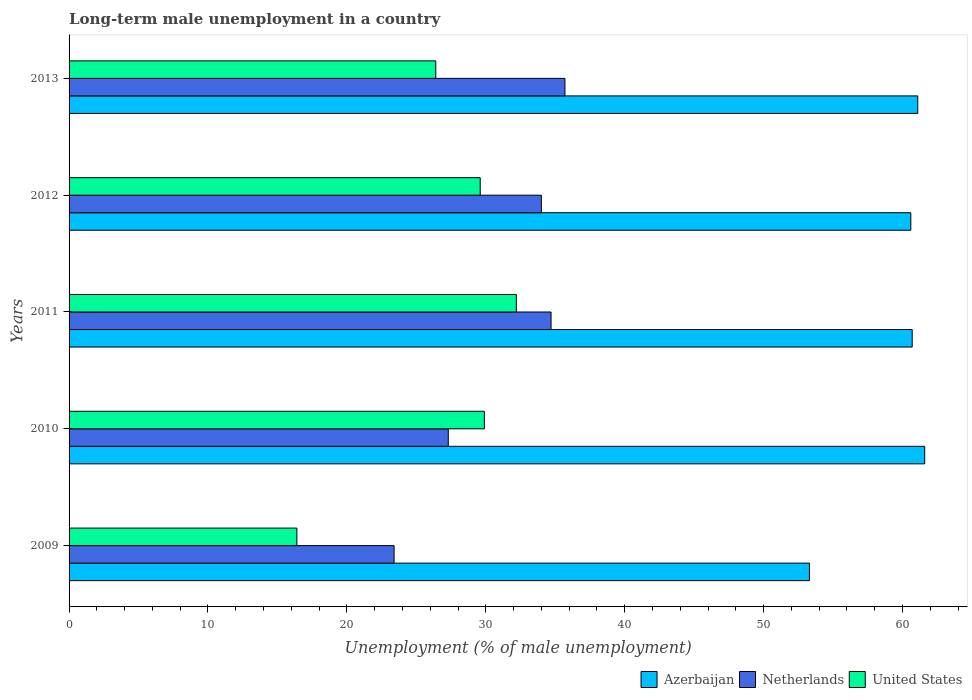Are the number of bars per tick equal to the number of legend labels?
Your answer should be very brief. Yes. How many bars are there on the 2nd tick from the top?
Offer a very short reply. 3. In how many cases, is the number of bars for a given year not equal to the number of legend labels?
Offer a very short reply. 0. What is the percentage of long-term unemployed male population in United States in 2013?
Offer a very short reply. 26.4. Across all years, what is the maximum percentage of long-term unemployed male population in United States?
Your answer should be compact. 32.2. Across all years, what is the minimum percentage of long-term unemployed male population in Netherlands?
Keep it short and to the point. 23.4. What is the total percentage of long-term unemployed male population in Netherlands in the graph?
Your response must be concise. 155.1. What is the difference between the percentage of long-term unemployed male population in United States in 2009 and that in 2012?
Your response must be concise. -13.2. What is the difference between the percentage of long-term unemployed male population in Netherlands in 2009 and the percentage of long-term unemployed male population in United States in 2013?
Your answer should be compact. -3. What is the average percentage of long-term unemployed male population in United States per year?
Your answer should be very brief. 26.9. In the year 2010, what is the difference between the percentage of long-term unemployed male population in United States and percentage of long-term unemployed male population in Netherlands?
Give a very brief answer. 2.6. In how many years, is the percentage of long-term unemployed male population in Netherlands greater than 56 %?
Your answer should be compact. 0. What is the ratio of the percentage of long-term unemployed male population in Azerbaijan in 2009 to that in 2011?
Provide a short and direct response. 0.88. Is the difference between the percentage of long-term unemployed male population in United States in 2009 and 2010 greater than the difference between the percentage of long-term unemployed male population in Netherlands in 2009 and 2010?
Your answer should be compact. No. What is the difference between the highest and the second highest percentage of long-term unemployed male population in United States?
Provide a succinct answer. 2.3. What is the difference between the highest and the lowest percentage of long-term unemployed male population in United States?
Provide a short and direct response. 15.8. Is the sum of the percentage of long-term unemployed male population in United States in 2012 and 2013 greater than the maximum percentage of long-term unemployed male population in Netherlands across all years?
Your response must be concise. Yes. How many bars are there?
Keep it short and to the point. 15. Does the graph contain grids?
Your answer should be very brief. No. Where does the legend appear in the graph?
Provide a succinct answer. Bottom right. How many legend labels are there?
Make the answer very short. 3. How are the legend labels stacked?
Give a very brief answer. Horizontal. What is the title of the graph?
Keep it short and to the point. Long-term male unemployment in a country. What is the label or title of the X-axis?
Your answer should be very brief. Unemployment (% of male unemployment). What is the Unemployment (% of male unemployment) in Azerbaijan in 2009?
Give a very brief answer. 53.3. What is the Unemployment (% of male unemployment) of Netherlands in 2009?
Your response must be concise. 23.4. What is the Unemployment (% of male unemployment) of United States in 2009?
Your response must be concise. 16.4. What is the Unemployment (% of male unemployment) in Azerbaijan in 2010?
Ensure brevity in your answer.  61.6. What is the Unemployment (% of male unemployment) in Netherlands in 2010?
Make the answer very short. 27.3. What is the Unemployment (% of male unemployment) of United States in 2010?
Make the answer very short. 29.9. What is the Unemployment (% of male unemployment) in Azerbaijan in 2011?
Your answer should be very brief. 60.7. What is the Unemployment (% of male unemployment) of Netherlands in 2011?
Provide a short and direct response. 34.7. What is the Unemployment (% of male unemployment) of United States in 2011?
Ensure brevity in your answer.  32.2. What is the Unemployment (% of male unemployment) of Azerbaijan in 2012?
Offer a terse response. 60.6. What is the Unemployment (% of male unemployment) of Netherlands in 2012?
Give a very brief answer. 34. What is the Unemployment (% of male unemployment) of United States in 2012?
Ensure brevity in your answer.  29.6. What is the Unemployment (% of male unemployment) in Azerbaijan in 2013?
Give a very brief answer. 61.1. What is the Unemployment (% of male unemployment) in Netherlands in 2013?
Your answer should be very brief. 35.7. What is the Unemployment (% of male unemployment) of United States in 2013?
Provide a short and direct response. 26.4. Across all years, what is the maximum Unemployment (% of male unemployment) of Azerbaijan?
Keep it short and to the point. 61.6. Across all years, what is the maximum Unemployment (% of male unemployment) of Netherlands?
Your response must be concise. 35.7. Across all years, what is the maximum Unemployment (% of male unemployment) in United States?
Provide a short and direct response. 32.2. Across all years, what is the minimum Unemployment (% of male unemployment) of Azerbaijan?
Your answer should be very brief. 53.3. Across all years, what is the minimum Unemployment (% of male unemployment) of Netherlands?
Your response must be concise. 23.4. Across all years, what is the minimum Unemployment (% of male unemployment) in United States?
Your answer should be very brief. 16.4. What is the total Unemployment (% of male unemployment) of Azerbaijan in the graph?
Provide a short and direct response. 297.3. What is the total Unemployment (% of male unemployment) in Netherlands in the graph?
Provide a succinct answer. 155.1. What is the total Unemployment (% of male unemployment) in United States in the graph?
Your response must be concise. 134.5. What is the difference between the Unemployment (% of male unemployment) in Azerbaijan in 2009 and that in 2010?
Your response must be concise. -8.3. What is the difference between the Unemployment (% of male unemployment) of Netherlands in 2009 and that in 2010?
Keep it short and to the point. -3.9. What is the difference between the Unemployment (% of male unemployment) in United States in 2009 and that in 2010?
Make the answer very short. -13.5. What is the difference between the Unemployment (% of male unemployment) in United States in 2009 and that in 2011?
Give a very brief answer. -15.8. What is the difference between the Unemployment (% of male unemployment) of Azerbaijan in 2009 and that in 2012?
Provide a short and direct response. -7.3. What is the difference between the Unemployment (% of male unemployment) in Netherlands in 2009 and that in 2012?
Give a very brief answer. -10.6. What is the difference between the Unemployment (% of male unemployment) of Azerbaijan in 2009 and that in 2013?
Keep it short and to the point. -7.8. What is the difference between the Unemployment (% of male unemployment) in Netherlands in 2009 and that in 2013?
Your answer should be compact. -12.3. What is the difference between the Unemployment (% of male unemployment) of United States in 2009 and that in 2013?
Offer a terse response. -10. What is the difference between the Unemployment (% of male unemployment) of Netherlands in 2010 and that in 2011?
Make the answer very short. -7.4. What is the difference between the Unemployment (% of male unemployment) in Azerbaijan in 2010 and that in 2012?
Provide a short and direct response. 1. What is the difference between the Unemployment (% of male unemployment) in Netherlands in 2010 and that in 2012?
Your response must be concise. -6.7. What is the difference between the Unemployment (% of male unemployment) in Azerbaijan in 2010 and that in 2013?
Your response must be concise. 0.5. What is the difference between the Unemployment (% of male unemployment) in Netherlands in 2010 and that in 2013?
Your answer should be compact. -8.4. What is the difference between the Unemployment (% of male unemployment) of Azerbaijan in 2011 and that in 2012?
Give a very brief answer. 0.1. What is the difference between the Unemployment (% of male unemployment) in Netherlands in 2011 and that in 2012?
Offer a terse response. 0.7. What is the difference between the Unemployment (% of male unemployment) of United States in 2011 and that in 2012?
Your response must be concise. 2.6. What is the difference between the Unemployment (% of male unemployment) of Azerbaijan in 2011 and that in 2013?
Make the answer very short. -0.4. What is the difference between the Unemployment (% of male unemployment) in Netherlands in 2011 and that in 2013?
Offer a terse response. -1. What is the difference between the Unemployment (% of male unemployment) of Azerbaijan in 2012 and that in 2013?
Provide a succinct answer. -0.5. What is the difference between the Unemployment (% of male unemployment) in United States in 2012 and that in 2013?
Provide a short and direct response. 3.2. What is the difference between the Unemployment (% of male unemployment) in Azerbaijan in 2009 and the Unemployment (% of male unemployment) in Netherlands in 2010?
Offer a very short reply. 26. What is the difference between the Unemployment (% of male unemployment) in Azerbaijan in 2009 and the Unemployment (% of male unemployment) in United States in 2010?
Your answer should be very brief. 23.4. What is the difference between the Unemployment (% of male unemployment) in Azerbaijan in 2009 and the Unemployment (% of male unemployment) in Netherlands in 2011?
Provide a succinct answer. 18.6. What is the difference between the Unemployment (% of male unemployment) in Azerbaijan in 2009 and the Unemployment (% of male unemployment) in United States in 2011?
Keep it short and to the point. 21.1. What is the difference between the Unemployment (% of male unemployment) in Netherlands in 2009 and the Unemployment (% of male unemployment) in United States in 2011?
Your response must be concise. -8.8. What is the difference between the Unemployment (% of male unemployment) of Azerbaijan in 2009 and the Unemployment (% of male unemployment) of Netherlands in 2012?
Provide a succinct answer. 19.3. What is the difference between the Unemployment (% of male unemployment) in Azerbaijan in 2009 and the Unemployment (% of male unemployment) in United States in 2012?
Make the answer very short. 23.7. What is the difference between the Unemployment (% of male unemployment) in Netherlands in 2009 and the Unemployment (% of male unemployment) in United States in 2012?
Provide a succinct answer. -6.2. What is the difference between the Unemployment (% of male unemployment) of Azerbaijan in 2009 and the Unemployment (% of male unemployment) of Netherlands in 2013?
Offer a very short reply. 17.6. What is the difference between the Unemployment (% of male unemployment) in Azerbaijan in 2009 and the Unemployment (% of male unemployment) in United States in 2013?
Make the answer very short. 26.9. What is the difference between the Unemployment (% of male unemployment) of Netherlands in 2009 and the Unemployment (% of male unemployment) of United States in 2013?
Offer a very short reply. -3. What is the difference between the Unemployment (% of male unemployment) of Azerbaijan in 2010 and the Unemployment (% of male unemployment) of Netherlands in 2011?
Your response must be concise. 26.9. What is the difference between the Unemployment (% of male unemployment) in Azerbaijan in 2010 and the Unemployment (% of male unemployment) in United States in 2011?
Offer a terse response. 29.4. What is the difference between the Unemployment (% of male unemployment) of Azerbaijan in 2010 and the Unemployment (% of male unemployment) of Netherlands in 2012?
Offer a terse response. 27.6. What is the difference between the Unemployment (% of male unemployment) in Netherlands in 2010 and the Unemployment (% of male unemployment) in United States in 2012?
Make the answer very short. -2.3. What is the difference between the Unemployment (% of male unemployment) of Azerbaijan in 2010 and the Unemployment (% of male unemployment) of Netherlands in 2013?
Make the answer very short. 25.9. What is the difference between the Unemployment (% of male unemployment) of Azerbaijan in 2010 and the Unemployment (% of male unemployment) of United States in 2013?
Offer a very short reply. 35.2. What is the difference between the Unemployment (% of male unemployment) in Azerbaijan in 2011 and the Unemployment (% of male unemployment) in Netherlands in 2012?
Your answer should be very brief. 26.7. What is the difference between the Unemployment (% of male unemployment) in Azerbaijan in 2011 and the Unemployment (% of male unemployment) in United States in 2012?
Your answer should be very brief. 31.1. What is the difference between the Unemployment (% of male unemployment) in Azerbaijan in 2011 and the Unemployment (% of male unemployment) in United States in 2013?
Your response must be concise. 34.3. What is the difference between the Unemployment (% of male unemployment) in Azerbaijan in 2012 and the Unemployment (% of male unemployment) in Netherlands in 2013?
Keep it short and to the point. 24.9. What is the difference between the Unemployment (% of male unemployment) in Azerbaijan in 2012 and the Unemployment (% of male unemployment) in United States in 2013?
Your response must be concise. 34.2. What is the average Unemployment (% of male unemployment) of Azerbaijan per year?
Give a very brief answer. 59.46. What is the average Unemployment (% of male unemployment) in Netherlands per year?
Provide a short and direct response. 31.02. What is the average Unemployment (% of male unemployment) in United States per year?
Your answer should be compact. 26.9. In the year 2009, what is the difference between the Unemployment (% of male unemployment) of Azerbaijan and Unemployment (% of male unemployment) of Netherlands?
Your answer should be compact. 29.9. In the year 2009, what is the difference between the Unemployment (% of male unemployment) of Azerbaijan and Unemployment (% of male unemployment) of United States?
Your answer should be very brief. 36.9. In the year 2010, what is the difference between the Unemployment (% of male unemployment) in Azerbaijan and Unemployment (% of male unemployment) in Netherlands?
Offer a very short reply. 34.3. In the year 2010, what is the difference between the Unemployment (% of male unemployment) of Azerbaijan and Unemployment (% of male unemployment) of United States?
Your answer should be very brief. 31.7. In the year 2010, what is the difference between the Unemployment (% of male unemployment) of Netherlands and Unemployment (% of male unemployment) of United States?
Give a very brief answer. -2.6. In the year 2012, what is the difference between the Unemployment (% of male unemployment) in Azerbaijan and Unemployment (% of male unemployment) in Netherlands?
Offer a terse response. 26.6. In the year 2013, what is the difference between the Unemployment (% of male unemployment) in Azerbaijan and Unemployment (% of male unemployment) in Netherlands?
Provide a succinct answer. 25.4. In the year 2013, what is the difference between the Unemployment (% of male unemployment) of Azerbaijan and Unemployment (% of male unemployment) of United States?
Provide a short and direct response. 34.7. In the year 2013, what is the difference between the Unemployment (% of male unemployment) of Netherlands and Unemployment (% of male unemployment) of United States?
Ensure brevity in your answer.  9.3. What is the ratio of the Unemployment (% of male unemployment) in Azerbaijan in 2009 to that in 2010?
Offer a terse response. 0.87. What is the ratio of the Unemployment (% of male unemployment) of Netherlands in 2009 to that in 2010?
Your answer should be very brief. 0.86. What is the ratio of the Unemployment (% of male unemployment) in United States in 2009 to that in 2010?
Provide a succinct answer. 0.55. What is the ratio of the Unemployment (% of male unemployment) of Azerbaijan in 2009 to that in 2011?
Provide a succinct answer. 0.88. What is the ratio of the Unemployment (% of male unemployment) in Netherlands in 2009 to that in 2011?
Provide a succinct answer. 0.67. What is the ratio of the Unemployment (% of male unemployment) of United States in 2009 to that in 2011?
Your answer should be very brief. 0.51. What is the ratio of the Unemployment (% of male unemployment) of Azerbaijan in 2009 to that in 2012?
Your answer should be compact. 0.88. What is the ratio of the Unemployment (% of male unemployment) in Netherlands in 2009 to that in 2012?
Your answer should be very brief. 0.69. What is the ratio of the Unemployment (% of male unemployment) in United States in 2009 to that in 2012?
Your response must be concise. 0.55. What is the ratio of the Unemployment (% of male unemployment) of Azerbaijan in 2009 to that in 2013?
Offer a terse response. 0.87. What is the ratio of the Unemployment (% of male unemployment) in Netherlands in 2009 to that in 2013?
Offer a very short reply. 0.66. What is the ratio of the Unemployment (% of male unemployment) in United States in 2009 to that in 2013?
Offer a terse response. 0.62. What is the ratio of the Unemployment (% of male unemployment) in Azerbaijan in 2010 to that in 2011?
Keep it short and to the point. 1.01. What is the ratio of the Unemployment (% of male unemployment) in Netherlands in 2010 to that in 2011?
Your answer should be very brief. 0.79. What is the ratio of the Unemployment (% of male unemployment) in United States in 2010 to that in 2011?
Provide a short and direct response. 0.93. What is the ratio of the Unemployment (% of male unemployment) of Azerbaijan in 2010 to that in 2012?
Your answer should be very brief. 1.02. What is the ratio of the Unemployment (% of male unemployment) of Netherlands in 2010 to that in 2012?
Give a very brief answer. 0.8. What is the ratio of the Unemployment (% of male unemployment) in Azerbaijan in 2010 to that in 2013?
Your answer should be compact. 1.01. What is the ratio of the Unemployment (% of male unemployment) of Netherlands in 2010 to that in 2013?
Ensure brevity in your answer.  0.76. What is the ratio of the Unemployment (% of male unemployment) in United States in 2010 to that in 2013?
Your answer should be very brief. 1.13. What is the ratio of the Unemployment (% of male unemployment) of Azerbaijan in 2011 to that in 2012?
Keep it short and to the point. 1. What is the ratio of the Unemployment (% of male unemployment) of Netherlands in 2011 to that in 2012?
Provide a short and direct response. 1.02. What is the ratio of the Unemployment (% of male unemployment) in United States in 2011 to that in 2012?
Give a very brief answer. 1.09. What is the ratio of the Unemployment (% of male unemployment) in Azerbaijan in 2011 to that in 2013?
Make the answer very short. 0.99. What is the ratio of the Unemployment (% of male unemployment) in Netherlands in 2011 to that in 2013?
Give a very brief answer. 0.97. What is the ratio of the Unemployment (% of male unemployment) of United States in 2011 to that in 2013?
Give a very brief answer. 1.22. What is the ratio of the Unemployment (% of male unemployment) in Azerbaijan in 2012 to that in 2013?
Your answer should be compact. 0.99. What is the ratio of the Unemployment (% of male unemployment) in United States in 2012 to that in 2013?
Keep it short and to the point. 1.12. What is the difference between the highest and the lowest Unemployment (% of male unemployment) of Azerbaijan?
Give a very brief answer. 8.3. What is the difference between the highest and the lowest Unemployment (% of male unemployment) of Netherlands?
Ensure brevity in your answer.  12.3. 